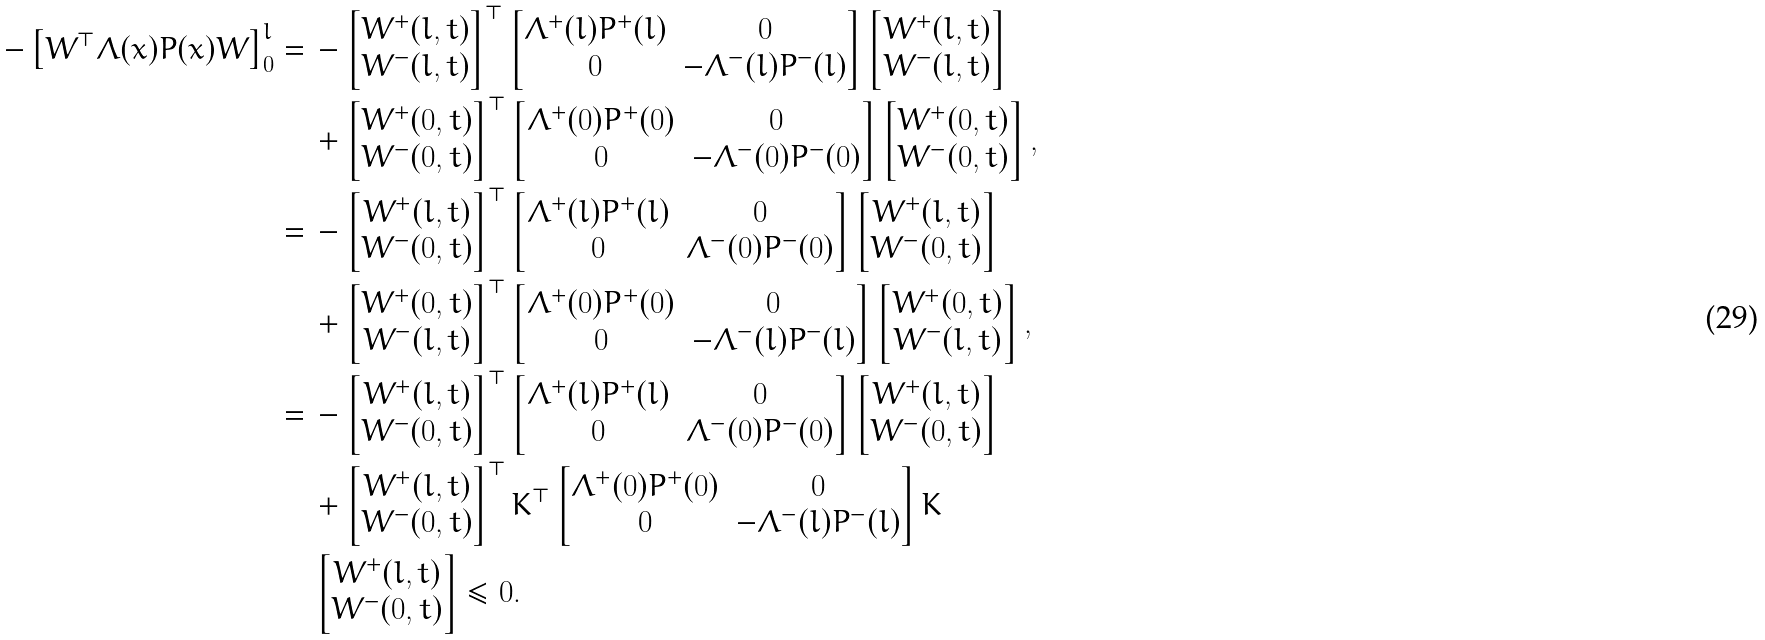Convert formula to latex. <formula><loc_0><loc_0><loc_500><loc_500>- \left [ { W ^ { \top } } \Lambda ( x ) P ( x ) W \right ] _ { 0 } ^ { l } = & \, - \begin{bmatrix} W ^ { + } ( l , t ) \\ W ^ { - } ( l , t ) \end{bmatrix} ^ { \top } \begin{bmatrix} \Lambda ^ { + } ( l ) P ^ { + } ( l ) & 0 \\ 0 & - \Lambda ^ { - } ( l ) P ^ { - } ( l ) \end{bmatrix} \begin{bmatrix} W ^ { + } ( l , t ) \\ W ^ { - } ( l , t ) \end{bmatrix} \\ & \, + \begin{bmatrix} W ^ { + } ( 0 , t ) \\ W ^ { - } ( 0 , t ) \end{bmatrix} ^ { \top } \begin{bmatrix} \Lambda ^ { + } ( 0 ) P ^ { + } ( 0 ) & 0 \\ 0 & - \Lambda ^ { - } ( 0 ) P ^ { - } ( 0 ) \end{bmatrix} \begin{bmatrix} W ^ { + } ( 0 , t ) \\ W ^ { - } ( 0 , t ) \end{bmatrix} , \\ = & \, - \begin{bmatrix} W ^ { + } ( l , t ) \\ W ^ { - } ( 0 , t ) \end{bmatrix} ^ { \top } \begin{bmatrix} \Lambda ^ { + } ( l ) P ^ { + } ( l ) & 0 \\ 0 & \Lambda ^ { - } ( 0 ) P ^ { - } ( 0 ) \end{bmatrix} \begin{bmatrix} W ^ { + } ( l , t ) \\ W ^ { - } ( 0 , t ) \end{bmatrix} \\ & \, + \begin{bmatrix} W ^ { + } ( 0 , t ) \\ W ^ { - } ( l , t ) \end{bmatrix} ^ { \top } \begin{bmatrix} \Lambda ^ { + } ( 0 ) P ^ { + } ( 0 ) & 0 \\ 0 & - \Lambda ^ { - } ( l ) P ^ { - } ( l ) \end{bmatrix} \begin{bmatrix} W ^ { + } ( 0 , t ) \\ W ^ { - } ( l , t ) \end{bmatrix} , \\ = & \, - \begin{bmatrix} W ^ { + } ( l , t ) \\ W ^ { - } ( 0 , t ) \end{bmatrix} ^ { \top } \begin{bmatrix} \Lambda ^ { + } ( l ) P ^ { + } ( l ) & 0 \\ 0 & \Lambda ^ { - } ( 0 ) P ^ { - } ( 0 ) \end{bmatrix} \begin{bmatrix} W ^ { + } ( l , t ) \\ W ^ { - } ( 0 , t ) \end{bmatrix} \\ & \, + \begin{bmatrix} W ^ { + } ( l , t ) \\ W ^ { - } ( 0 , t ) \end{bmatrix} ^ { \top } K ^ { \top } \begin{bmatrix} \Lambda ^ { + } ( 0 ) P ^ { + } ( 0 ) & 0 \\ 0 & - \Lambda ^ { - } ( l ) P ^ { - } ( l ) \end{bmatrix} K \\ & \, \begin{bmatrix} W ^ { + } ( l , t ) \\ W ^ { - } ( 0 , t ) \end{bmatrix} \leq 0 .</formula> 